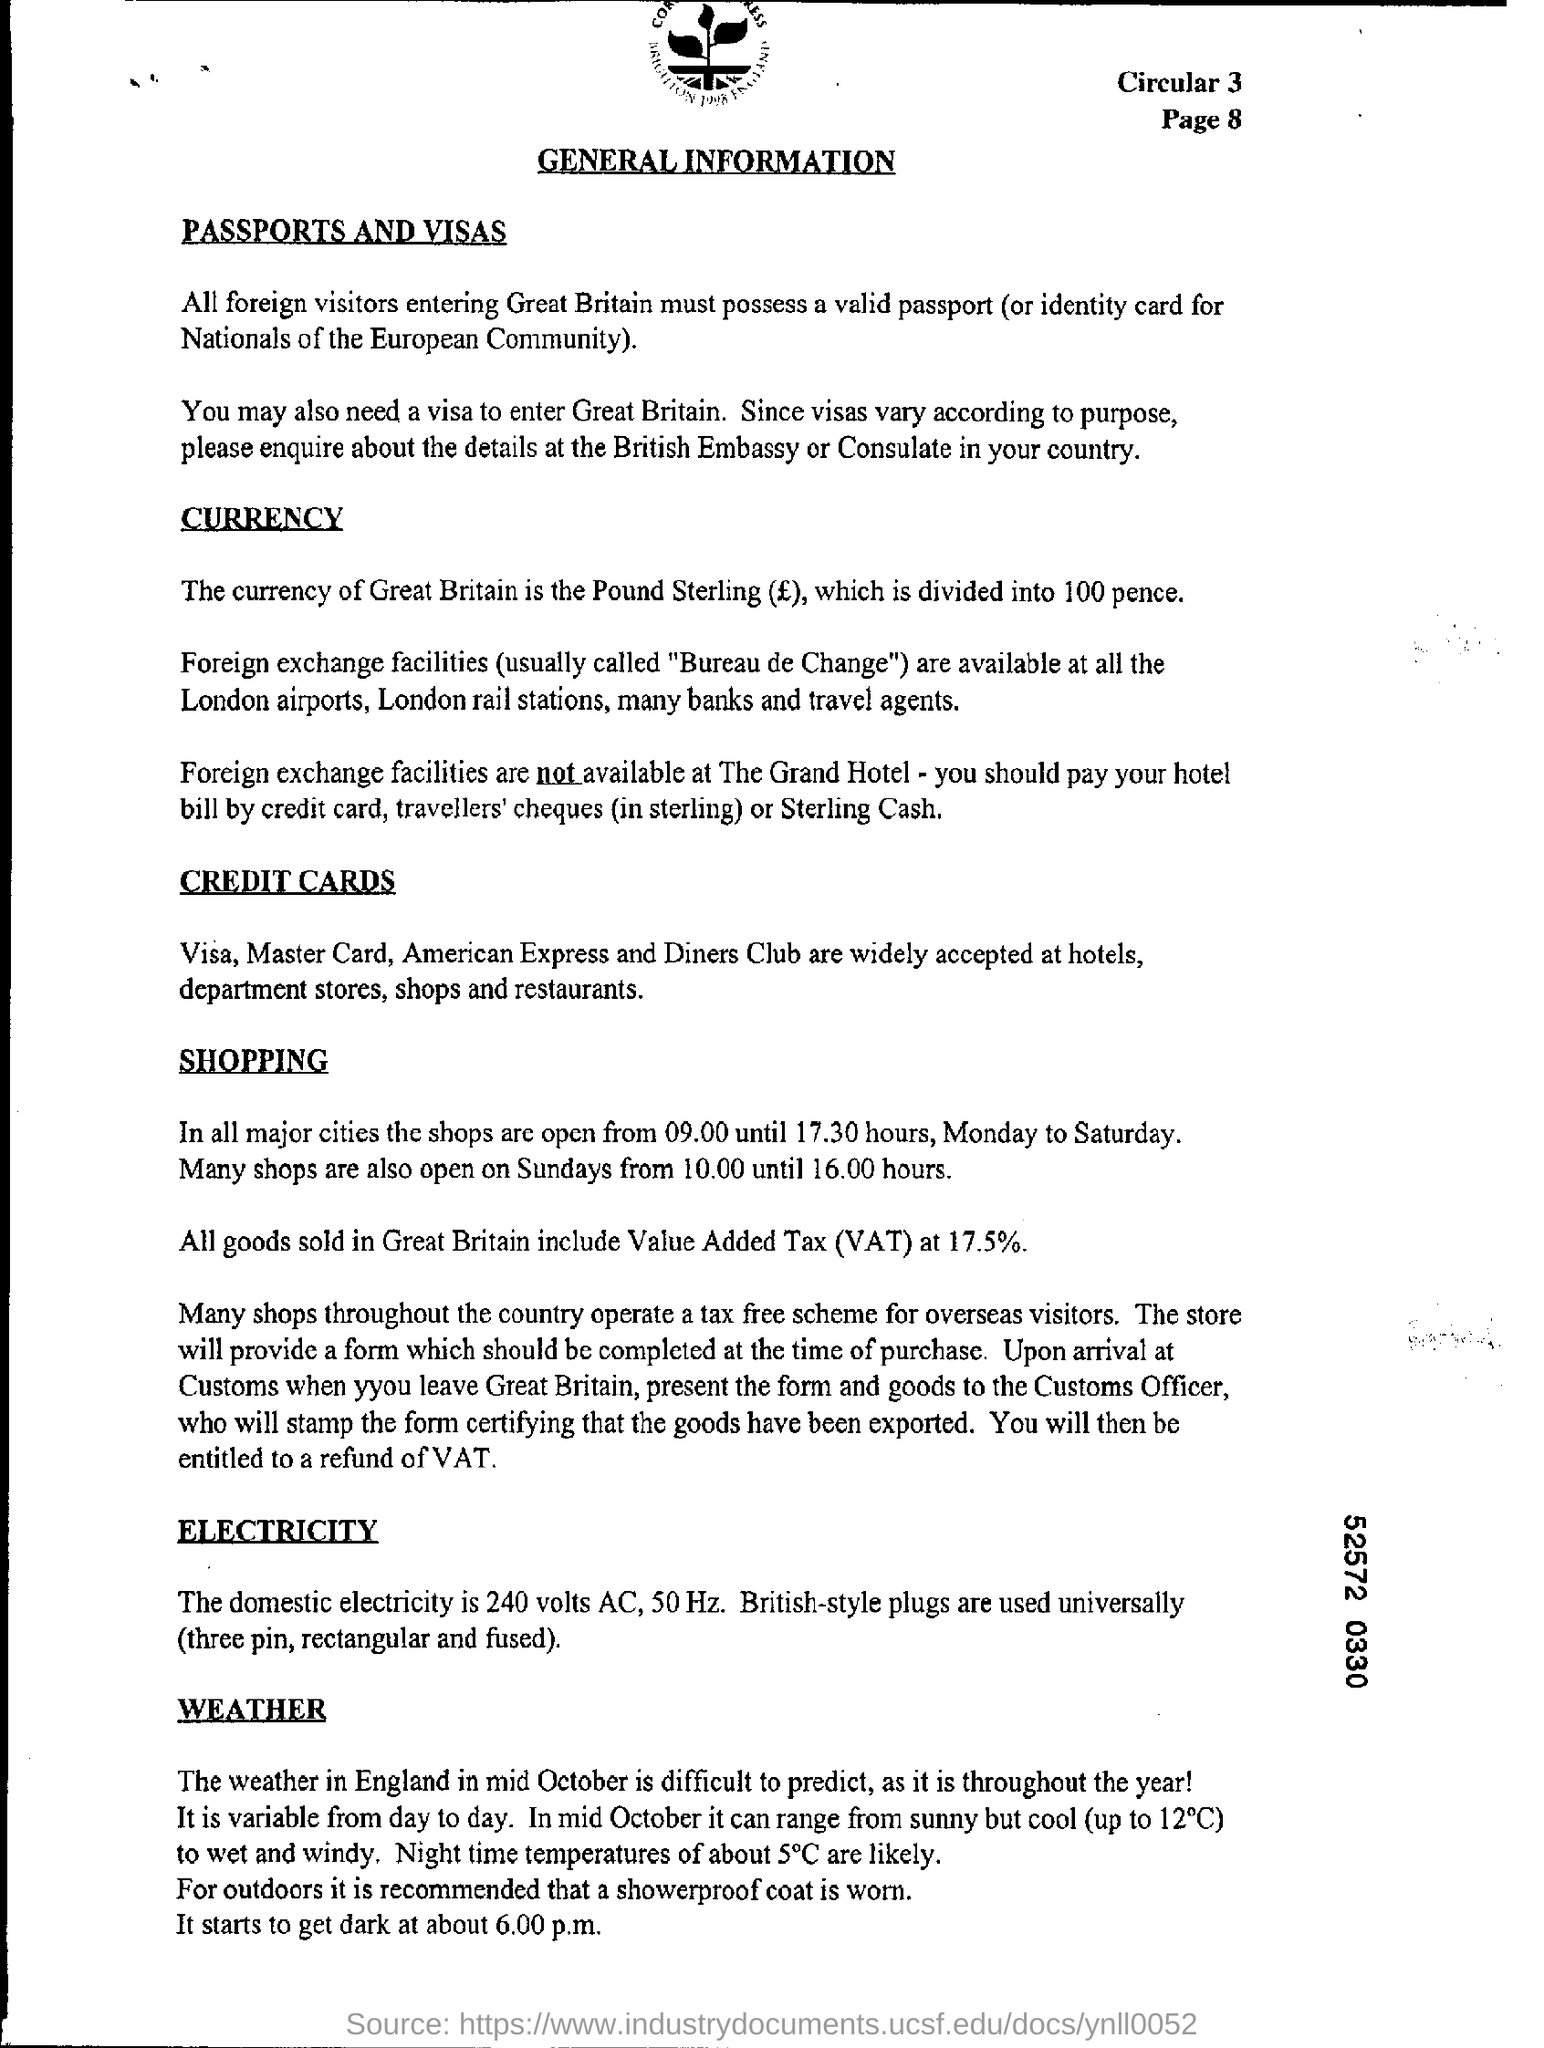Give some essential details in this illustration. The currency of Great Britain is pound sterling. 